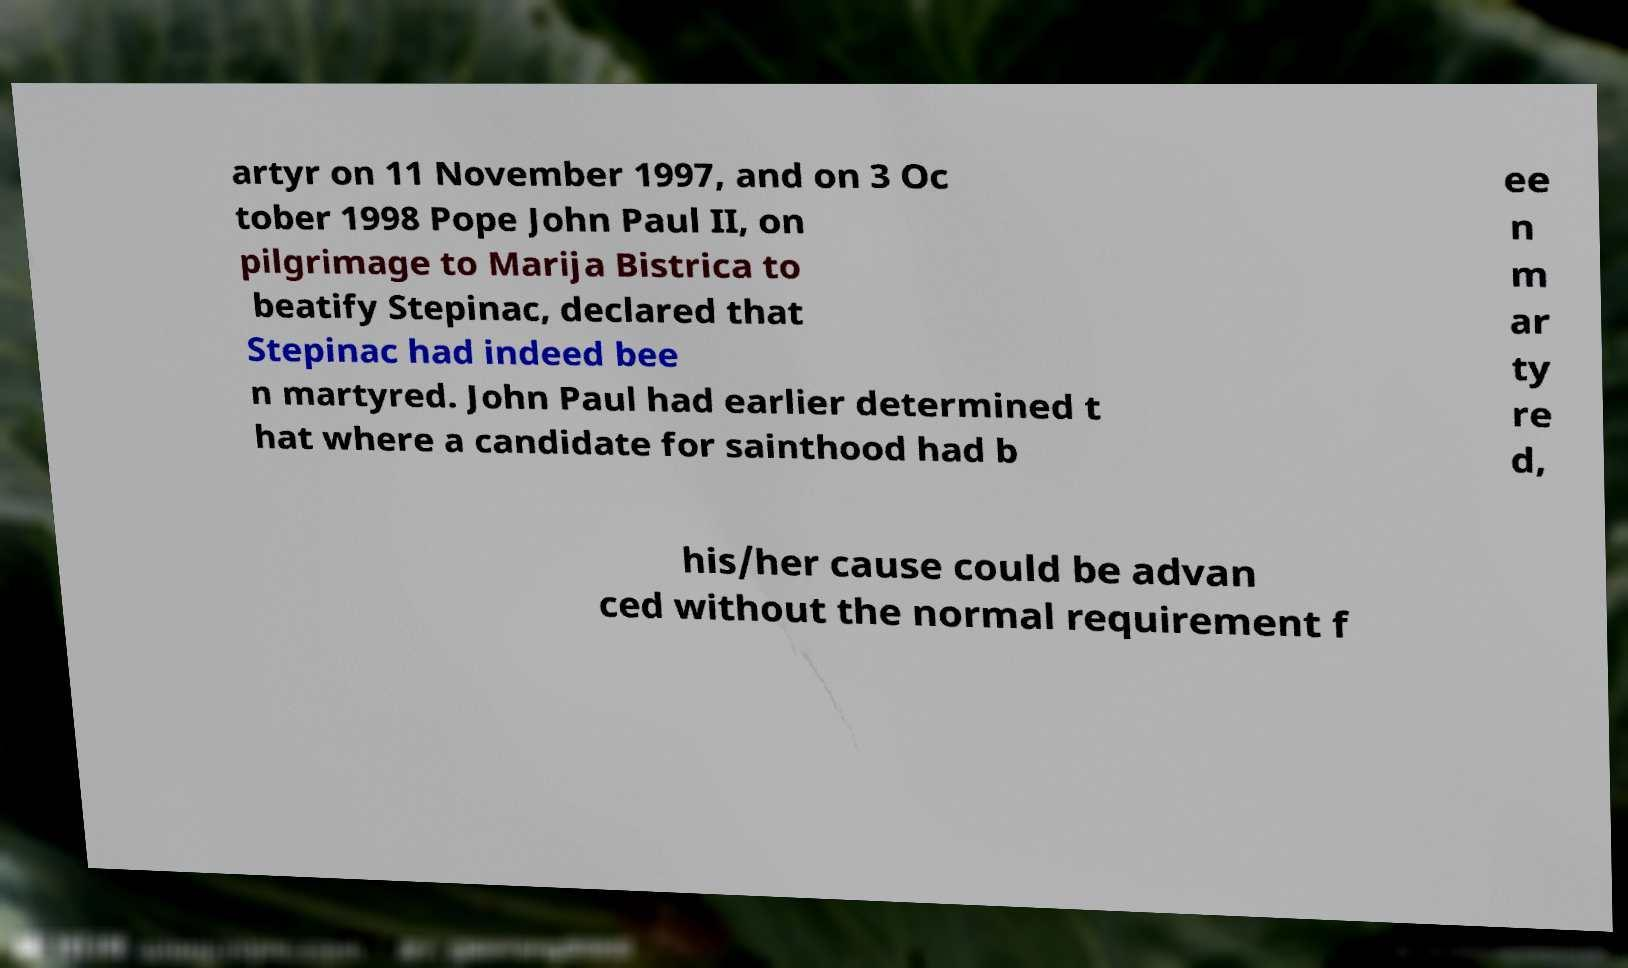I need the written content from this picture converted into text. Can you do that? artyr on 11 November 1997, and on 3 Oc tober 1998 Pope John Paul II, on pilgrimage to Marija Bistrica to beatify Stepinac, declared that Stepinac had indeed bee n martyred. John Paul had earlier determined t hat where a candidate for sainthood had b ee n m ar ty re d, his/her cause could be advan ced without the normal requirement f 